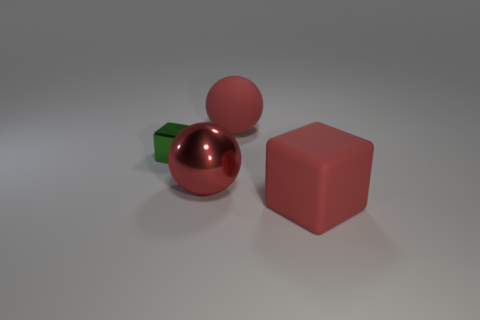Add 2 tiny green shiny cubes. How many objects exist? 6 Subtract all green blocks. How many blocks are left? 1 Subtract 1 balls. How many balls are left? 1 Subtract all green blocks. Subtract all yellow spheres. How many blocks are left? 1 Subtract all purple spheres. How many red cubes are left? 1 Subtract all big red matte things. Subtract all large rubber balls. How many objects are left? 1 Add 2 green objects. How many green objects are left? 3 Add 4 small blocks. How many small blocks exist? 5 Subtract 0 purple blocks. How many objects are left? 4 